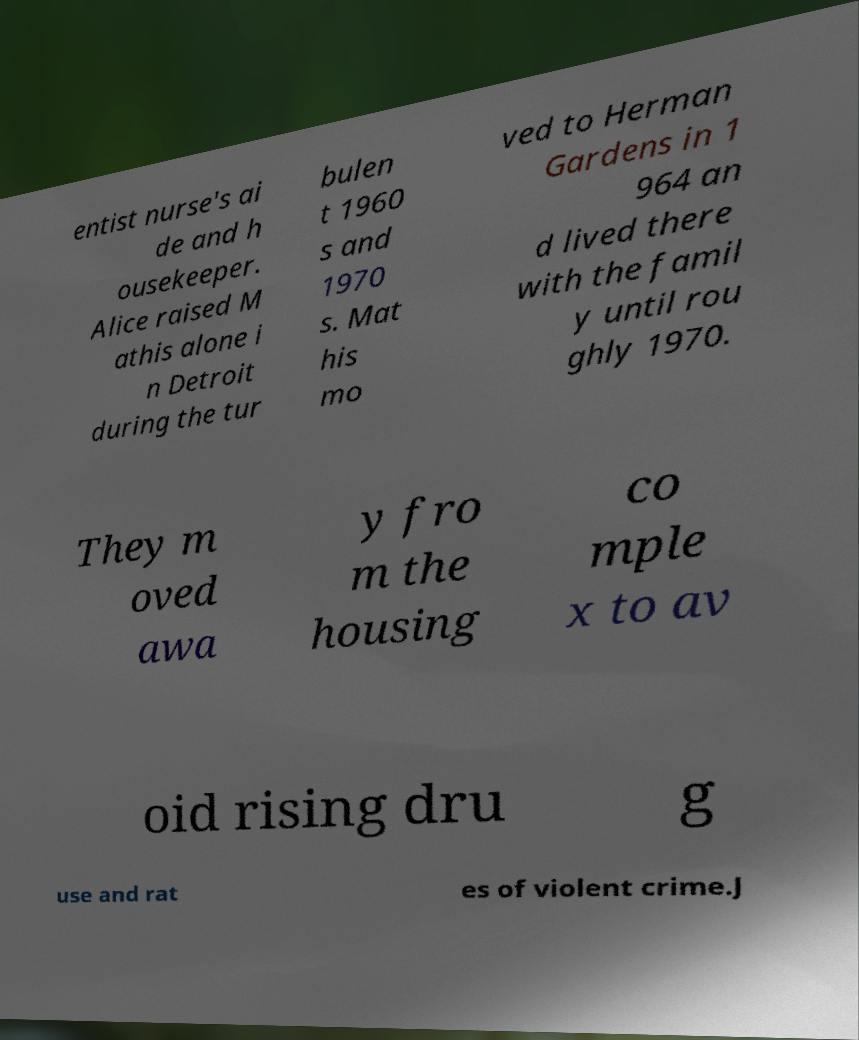For documentation purposes, I need the text within this image transcribed. Could you provide that? entist nurse's ai de and h ousekeeper. Alice raised M athis alone i n Detroit during the tur bulen t 1960 s and 1970 s. Mat his mo ved to Herman Gardens in 1 964 an d lived there with the famil y until rou ghly 1970. They m oved awa y fro m the housing co mple x to av oid rising dru g use and rat es of violent crime.J 